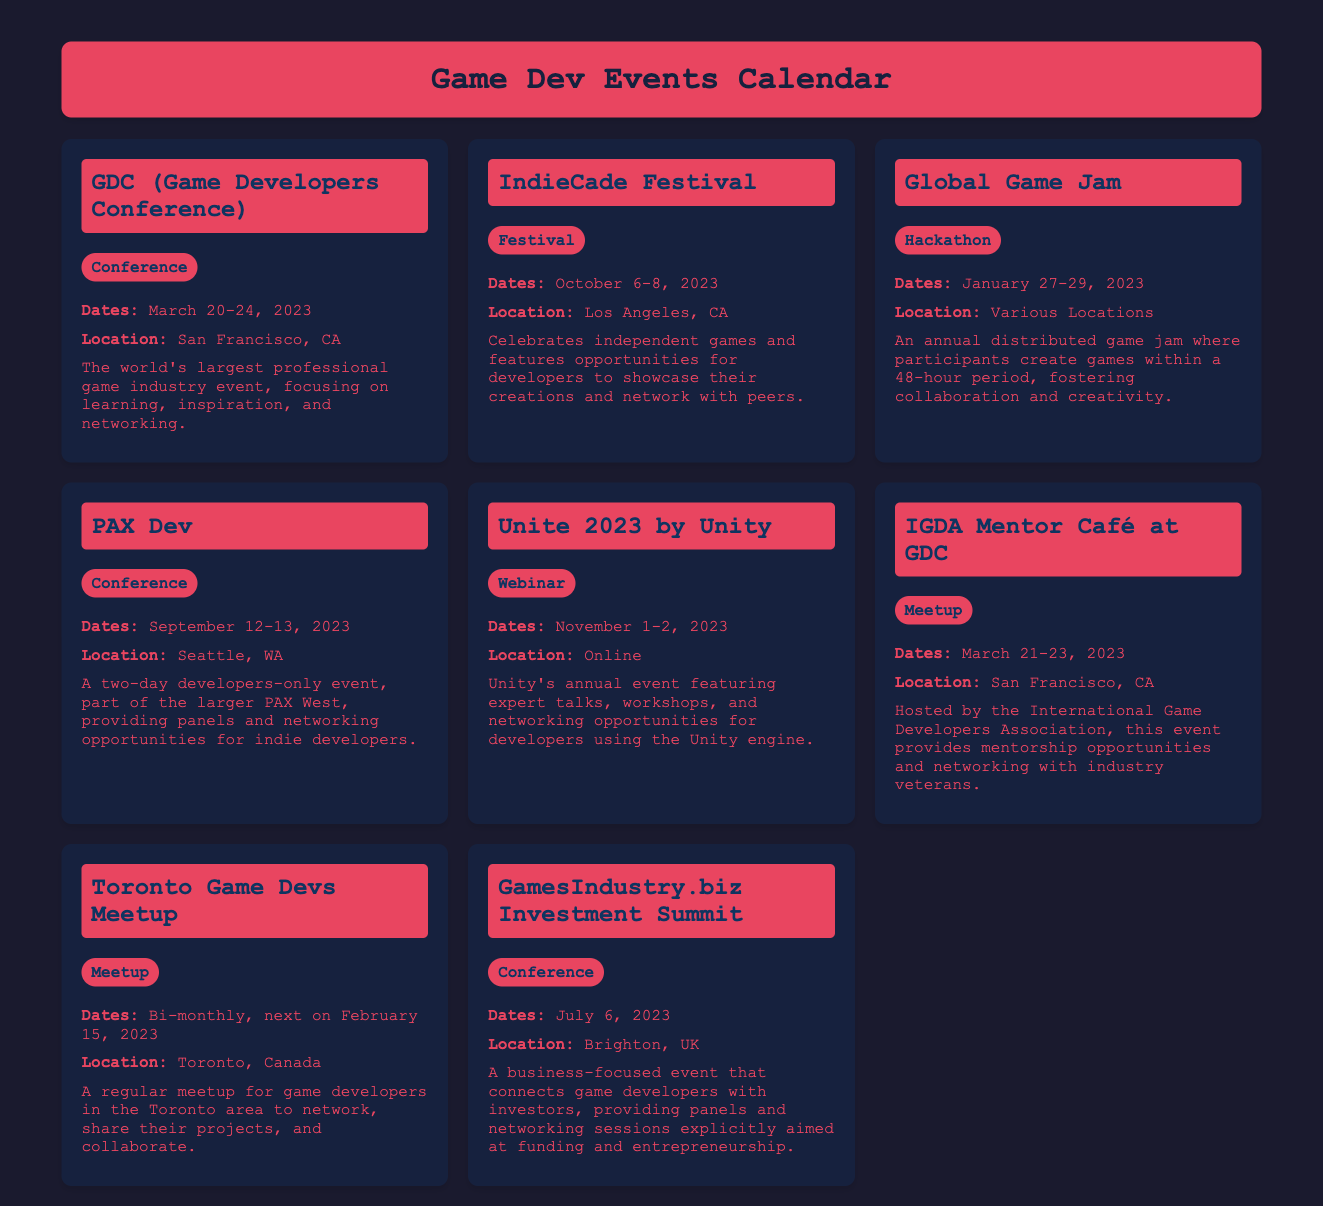what are the dates for the IndieCade Festival? The event takes place from October 6-8, 2023.
Answer: October 6-8, 2023 where is GDC held? The location for GDC is San Francisco, CA.
Answer: San Francisco, CA what type of event is PAX Dev? PAX Dev is categorized as a conference.
Answer: Conference when is the next Toronto Game Devs Meetup? The next meetup is on February 15, 2023.
Answer: February 15, 2023 who hosts the IGDA Mentor Café? The event is hosted by the International Game Developers Association.
Answer: International Game Developers Association how many days does the Global Game Jam last? It lasts for 48 hours, which is 2 days.
Answer: 48 hours what is the focus of the GamesIndustry.biz Investment Summit? It connects game developers with investors.
Answer: Connecting game developers with investors what is the location for the Unite 2023 webinar? The webinar is held online.
Answer: Online how often does the Toronto Game Devs Meetup occur? The meetup is bi-monthly.
Answer: Bi-monthly 